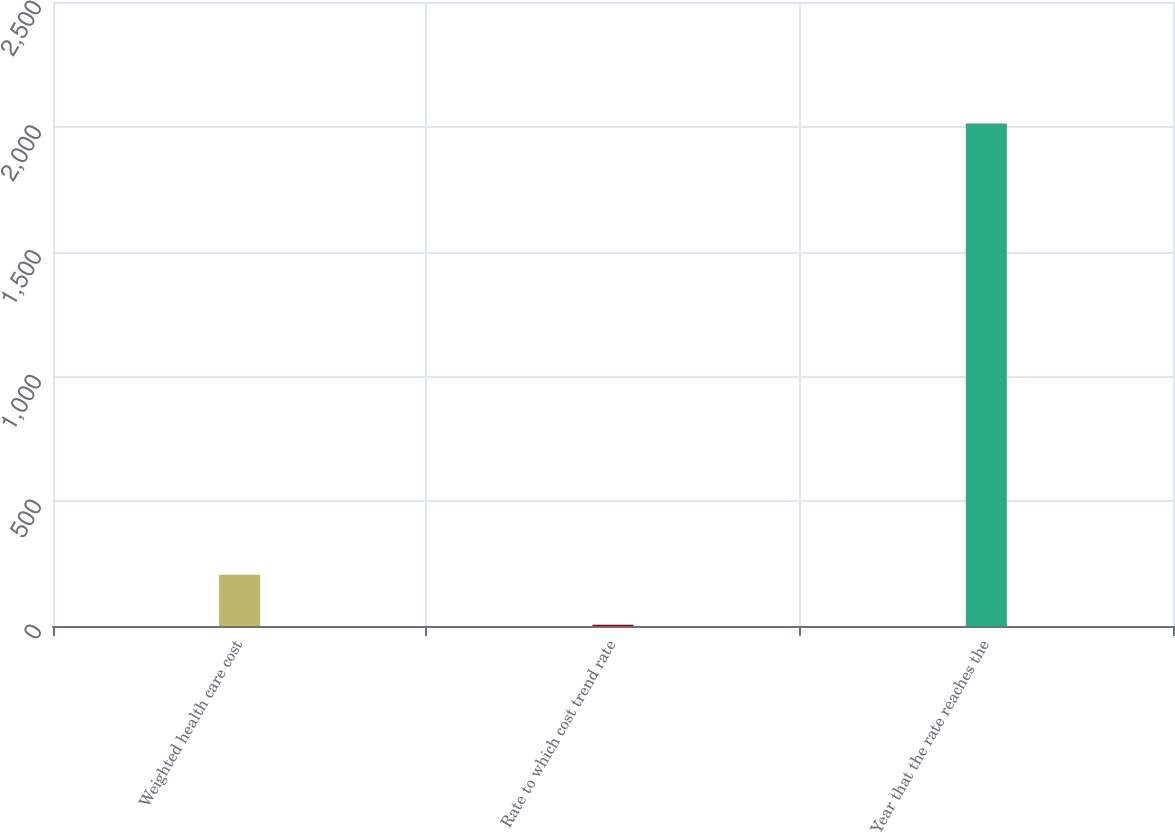Convert chart to OTSL. <chart><loc_0><loc_0><loc_500><loc_500><bar_chart><fcel>Weighted health care cost<fcel>Rate to which cost trend rate<fcel>Year that the rate reaches the<nl><fcel>205.8<fcel>5<fcel>2013<nl></chart> 